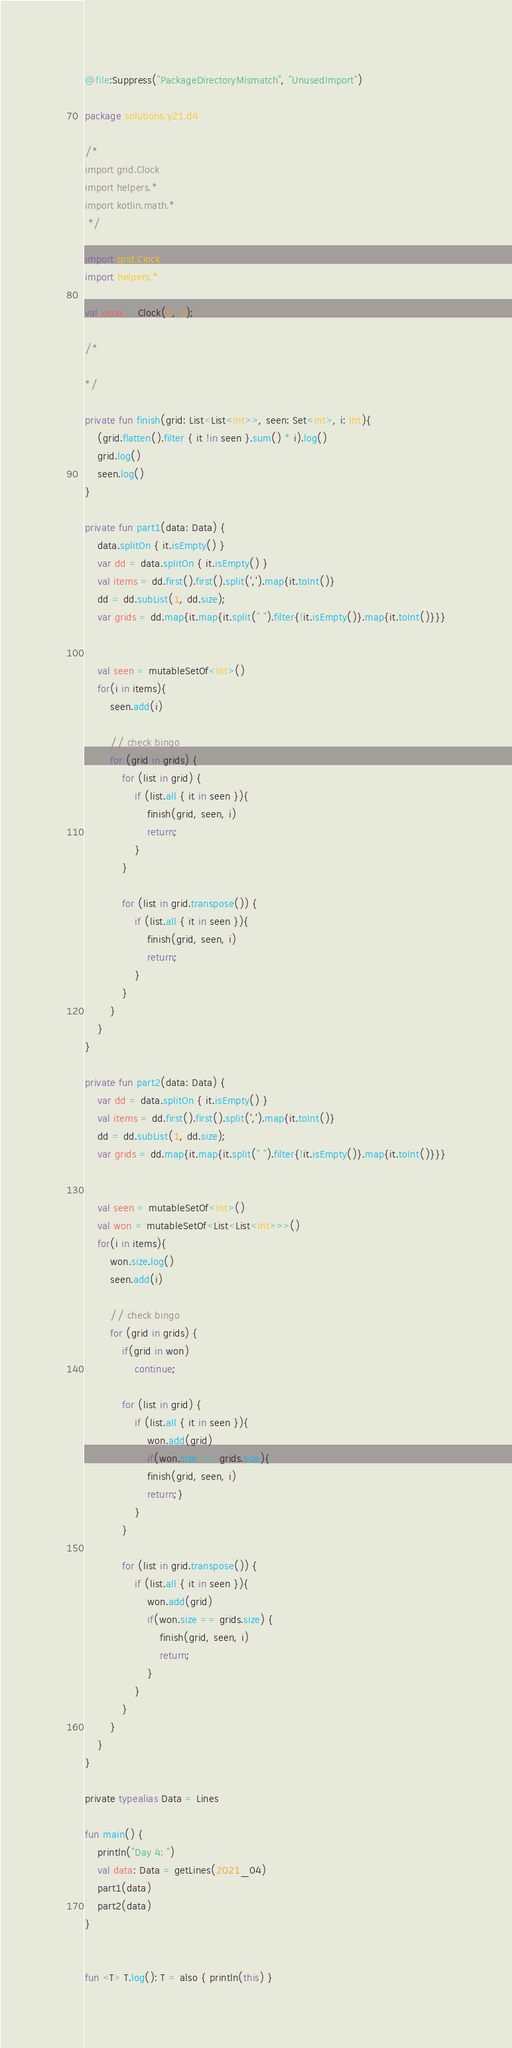<code> <loc_0><loc_0><loc_500><loc_500><_Kotlin_>@file:Suppress("PackageDirectoryMismatch", "UnusedImport")

package solutions.y21.d4

/*
import grid.Clock
import helpers.*
import kotlin.math.*
 */

import grid.Clock
import helpers.*

val xxxxx = Clock(6, 3);

/*

*/

private fun finish(grid: List<List<Int>>, seen: Set<Int>, i: Int){
    (grid.flatten().filter { it !in seen }.sum() * i).log()
    grid.log()
    seen.log()
}

private fun part1(data: Data) {
    data.splitOn { it.isEmpty() }
    var dd = data.splitOn { it.isEmpty() }
    val items = dd.first().first().split(',').map{it.toInt()}
    dd = dd.subList(1, dd.size);
    var grids = dd.map{it.map{it.split(" ").filter{!it.isEmpty()}.map{it.toInt()}}}


    val seen = mutableSetOf<Int>()
    for(i in items){
        seen.add(i)

        // check bingo
        for (grid in grids) {
            for (list in grid) {
                if (list.all { it in seen }){
                    finish(grid, seen, i)
                    return;
                }
            }

            for (list in grid.transpose()) {
                if (list.all { it in seen }){
                    finish(grid, seen, i)
                    return;
                }
            }
        }
    }
}

private fun part2(data: Data) {
    var dd = data.splitOn { it.isEmpty() }
    val items = dd.first().first().split(',').map{it.toInt()}
    dd = dd.subList(1, dd.size);
    var grids = dd.map{it.map{it.split(" ").filter{!it.isEmpty()}.map{it.toInt()}}}


    val seen = mutableSetOf<Int>()
    val won = mutableSetOf<List<List<Int>>>()
    for(i in items){
        won.size.log()
        seen.add(i)

        // check bingo
        for (grid in grids) {
            if(grid in won)
                continue;

            for (list in grid) {
                if (list.all { it in seen }){
                    won.add(grid)
                    if(won.size == grids.size){
                    finish(grid, seen, i)
                    return;}
                }
            }

            for (list in grid.transpose()) {
                if (list.all { it in seen }){
                    won.add(grid)
                    if(won.size == grids.size) {
                        finish(grid, seen, i)
                        return;
                    }
                }
            }
        }
    }
}

private typealias Data = Lines

fun main() {
    println("Day 4: ")
    val data: Data = getLines(2021_04)
    part1(data)
    part2(data)
}


fun <T> T.log(): T = also { println(this) }</code> 